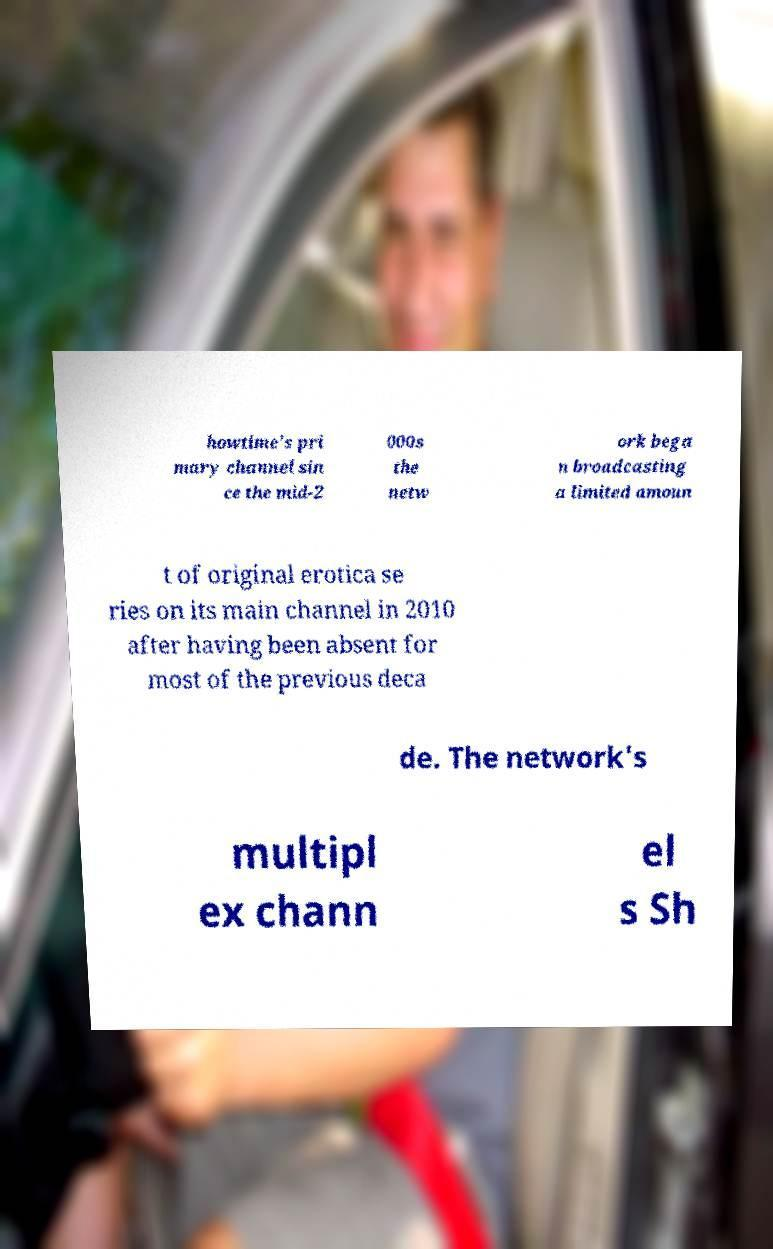There's text embedded in this image that I need extracted. Can you transcribe it verbatim? howtime's pri mary channel sin ce the mid-2 000s the netw ork bega n broadcasting a limited amoun t of original erotica se ries on its main channel in 2010 after having been absent for most of the previous deca de. The network's multipl ex chann el s Sh 